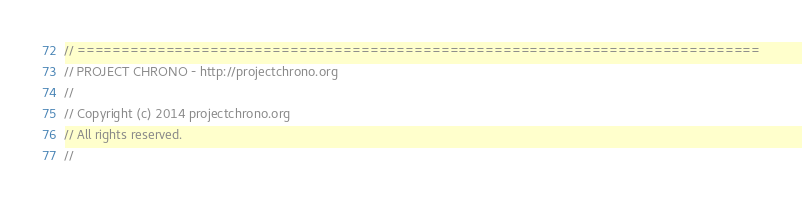<code> <loc_0><loc_0><loc_500><loc_500><_C++_>// =============================================================================
// PROJECT CHRONO - http://projectchrono.org
//
// Copyright (c) 2014 projectchrono.org
// All rights reserved.
//</code> 